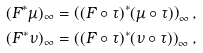<formula> <loc_0><loc_0><loc_500><loc_500>( F ^ { * } \mu ) _ { \infty } & = \left ( ( F \circ \tau ) ^ { * } ( \mu \circ \tau ) \right ) _ { \infty } , \\ ( F ^ { * } \nu ) _ { \infty } & = \left ( ( F \circ \tau ) ^ { * } ( \nu \circ \tau ) \right ) _ { \infty } ,</formula> 